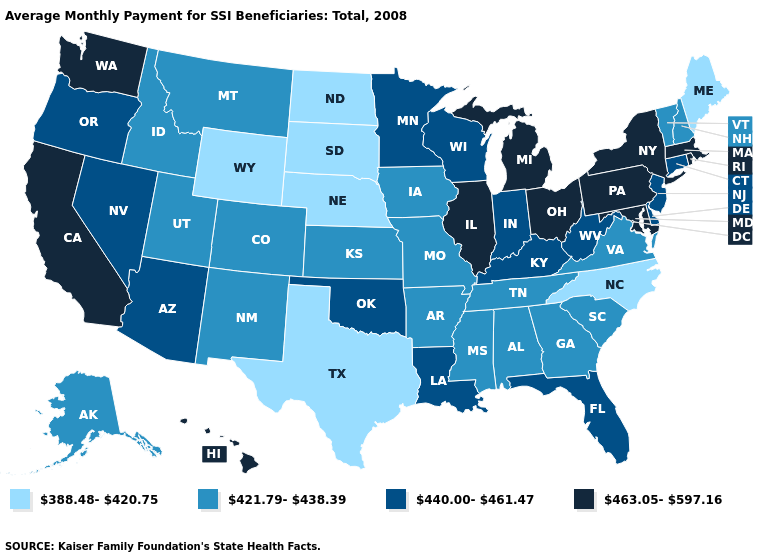Name the states that have a value in the range 463.05-597.16?
Keep it brief. California, Hawaii, Illinois, Maryland, Massachusetts, Michigan, New York, Ohio, Pennsylvania, Rhode Island, Washington. Which states have the highest value in the USA?
Short answer required. California, Hawaii, Illinois, Maryland, Massachusetts, Michigan, New York, Ohio, Pennsylvania, Rhode Island, Washington. Name the states that have a value in the range 421.79-438.39?
Write a very short answer. Alabama, Alaska, Arkansas, Colorado, Georgia, Idaho, Iowa, Kansas, Mississippi, Missouri, Montana, New Hampshire, New Mexico, South Carolina, Tennessee, Utah, Vermont, Virginia. What is the value of Hawaii?
Short answer required. 463.05-597.16. What is the value of Texas?
Keep it brief. 388.48-420.75. What is the value of Maine?
Give a very brief answer. 388.48-420.75. How many symbols are there in the legend?
Quick response, please. 4. Among the states that border Virginia , does Tennessee have the highest value?
Quick response, please. No. Does the first symbol in the legend represent the smallest category?
Keep it brief. Yes. Name the states that have a value in the range 421.79-438.39?
Give a very brief answer. Alabama, Alaska, Arkansas, Colorado, Georgia, Idaho, Iowa, Kansas, Mississippi, Missouri, Montana, New Hampshire, New Mexico, South Carolina, Tennessee, Utah, Vermont, Virginia. What is the lowest value in states that border Virginia?
Answer briefly. 388.48-420.75. Among the states that border Utah , which have the highest value?
Keep it brief. Arizona, Nevada. Name the states that have a value in the range 388.48-420.75?
Concise answer only. Maine, Nebraska, North Carolina, North Dakota, South Dakota, Texas, Wyoming. What is the lowest value in the West?
Be succinct. 388.48-420.75. Name the states that have a value in the range 421.79-438.39?
Be succinct. Alabama, Alaska, Arkansas, Colorado, Georgia, Idaho, Iowa, Kansas, Mississippi, Missouri, Montana, New Hampshire, New Mexico, South Carolina, Tennessee, Utah, Vermont, Virginia. 